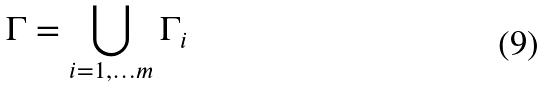<formula> <loc_0><loc_0><loc_500><loc_500>\Gamma = \bigcup _ { i = 1 , \dots m } \Gamma _ { i }</formula> 